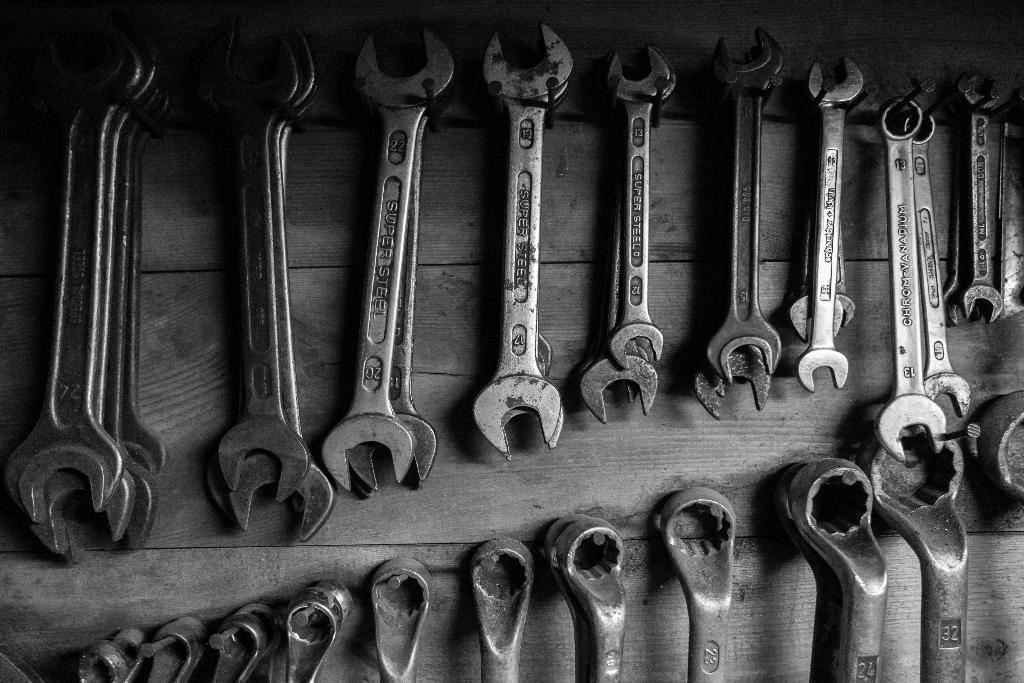What types of wrenches are visible in the image? There are open end wrenches and box end wrenches of different sizes in the image. What is the surface at the bottom of the image made of? The surface at the bottom of the image is made of wood. What type of pollution can be seen in the image? There is no pollution visible in the image; it features wrenches on a wooden surface. How many wrenches are being crushed in the image? There are no wrenches being crushed in the image; they are all visible and intact. 